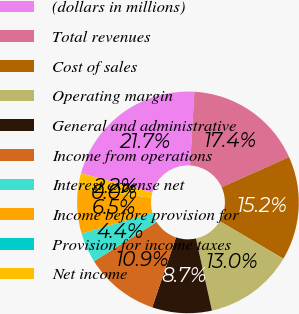<chart> <loc_0><loc_0><loc_500><loc_500><pie_chart><fcel>(dollars in millions)<fcel>Total revenues<fcel>Cost of sales<fcel>Operating margin<fcel>General and administrative<fcel>Income from operations<fcel>Interest expense net<fcel>Income before provision for<fcel>Provision for income taxes<fcel>Net income<nl><fcel>21.7%<fcel>17.37%<fcel>15.2%<fcel>13.03%<fcel>8.7%<fcel>10.87%<fcel>4.37%<fcel>6.53%<fcel>0.03%<fcel>2.2%<nl></chart> 